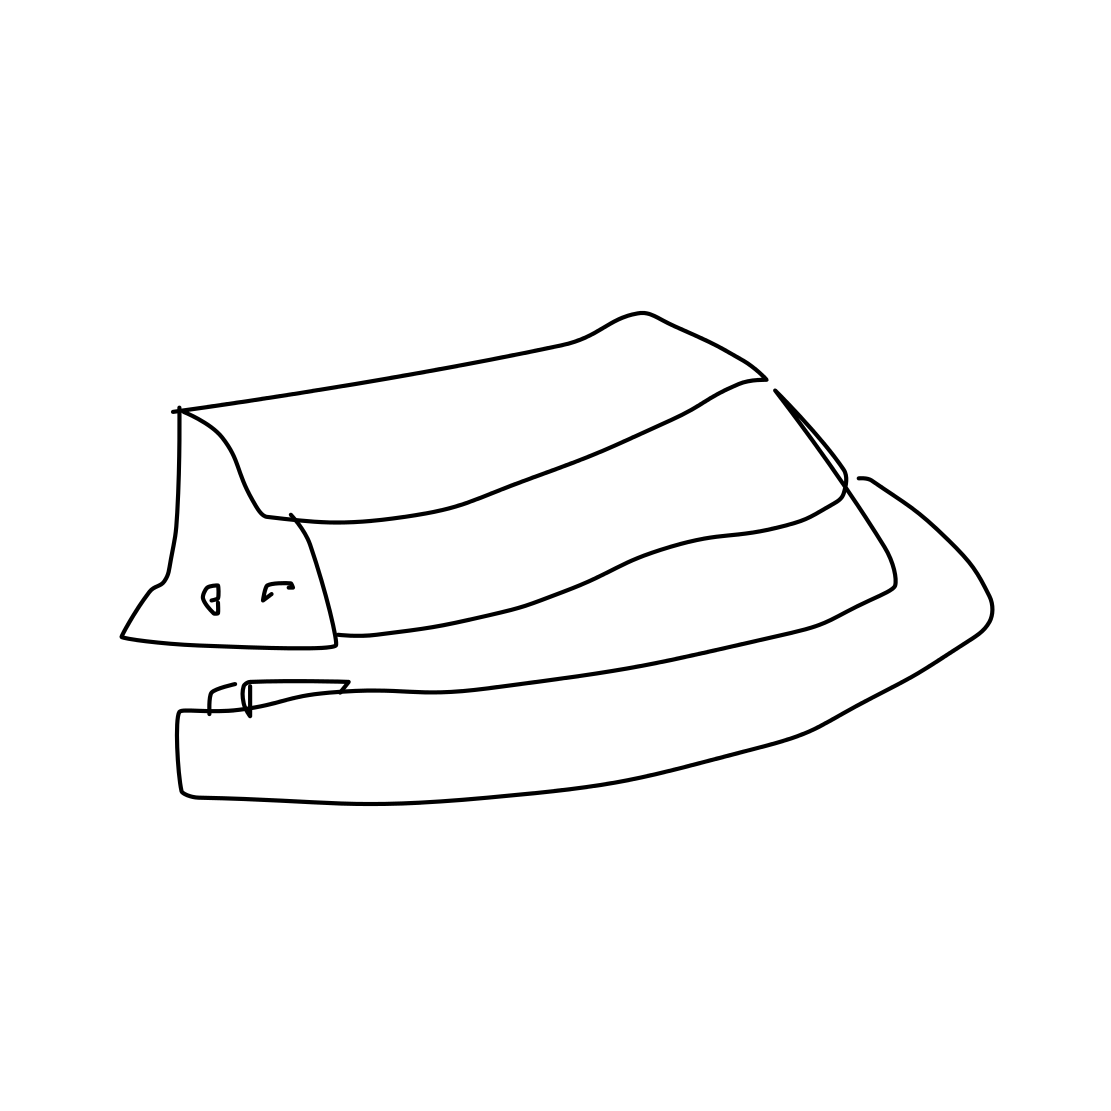What type of hat is shown in this image? This simple line drawing represents a fedora hat, identifiable by its creased crown and a pinched front. 